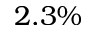Convert formula to latex. <formula><loc_0><loc_0><loc_500><loc_500>2 . 3 \%</formula> 